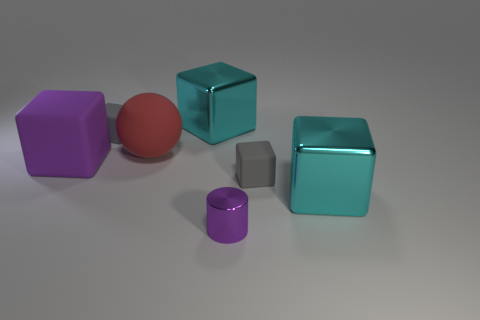Subtract all big purple cubes. How many cubes are left? 4 Subtract all red cylinders. How many cyan cubes are left? 2 Add 3 small purple things. How many objects exist? 10 Subtract all cyan cubes. How many cubes are left? 3 Subtract all spheres. How many objects are left? 6 Subtract 1 cubes. How many cubes are left? 4 Add 5 large red matte objects. How many large red matte objects exist? 6 Subtract 0 green spheres. How many objects are left? 7 Subtract all purple balls. Subtract all red blocks. How many balls are left? 1 Subtract all tiny gray cubes. Subtract all cyan shiny blocks. How many objects are left? 3 